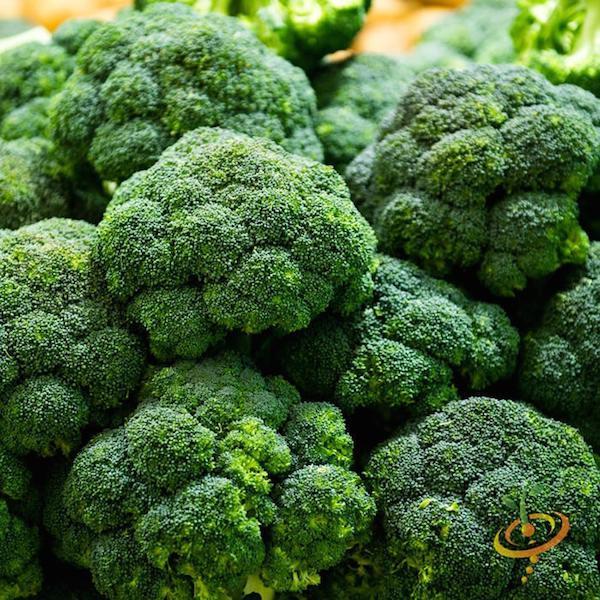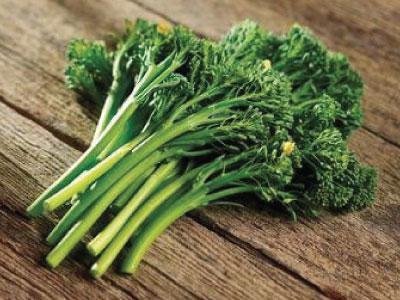The first image is the image on the left, the second image is the image on the right. Evaluate the accuracy of this statement regarding the images: "Broccoli is shown in both images, but in one it is a plant in the garden and in the other, it is cleaned for eating or cooking.". Is it true? Answer yes or no. No. The first image is the image on the left, the second image is the image on the right. Assess this claim about the two images: "An image shows broccoli growing in soil, with leaves surrounding the florets.". Correct or not? Answer yes or no. No. 